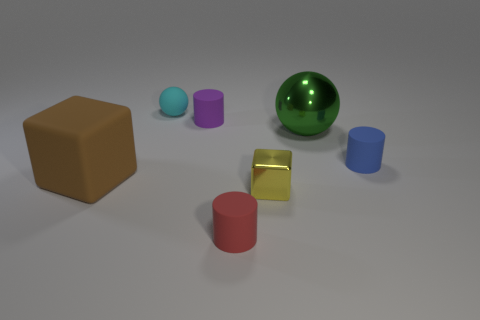Is there anything else of the same color as the big metal object?
Provide a short and direct response. No. What is the shape of the rubber thing that is to the right of the small red matte thing?
Offer a terse response. Cylinder. There is a rubber sphere; is its color the same as the cube that is left of the cyan matte object?
Your response must be concise. No. Are there the same number of tiny rubber spheres in front of the big green metallic object and small red rubber objects that are right of the small red cylinder?
Your answer should be compact. Yes. How many other things are the same size as the metallic block?
Your answer should be very brief. 4. How big is the brown rubber object?
Provide a short and direct response. Large. Is the material of the blue thing the same as the thing behind the purple cylinder?
Give a very brief answer. Yes. Is there a green metallic thing of the same shape as the purple rubber object?
Your answer should be compact. No. What material is the brown object that is the same size as the metal sphere?
Keep it short and to the point. Rubber. How big is the ball that is to the right of the small rubber ball?
Provide a short and direct response. Large. 